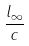<formula> <loc_0><loc_0><loc_500><loc_500>\frac { l _ { \infty } } { c }</formula> 